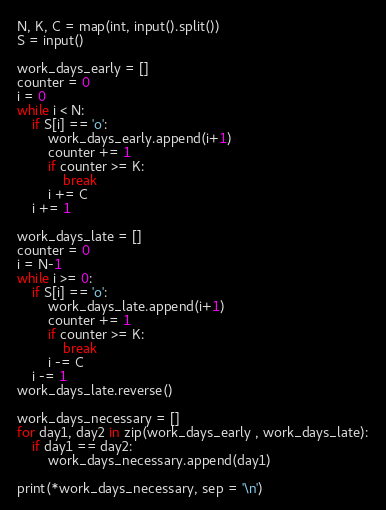<code> <loc_0><loc_0><loc_500><loc_500><_Python_>N, K, C = map(int, input().split())
S = input()

work_days_early = []
counter = 0
i = 0
while i < N:
    if S[i] == 'o':
        work_days_early.append(i+1)
        counter += 1
        if counter >= K:
            break
        i += C
    i += 1

work_days_late = []
counter = 0
i = N-1
while i >= 0:
    if S[i] == 'o':
        work_days_late.append(i+1)
        counter += 1
        if counter >= K:
            break
        i -= C
    i -= 1
work_days_late.reverse()

work_days_necessary = []
for day1, day2 in zip(work_days_early , work_days_late):
    if day1 == day2:
        work_days_necessary.append(day1)

print(*work_days_necessary, sep = '\n')</code> 